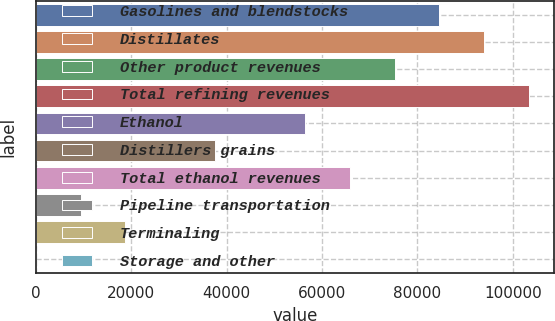Convert chart. <chart><loc_0><loc_0><loc_500><loc_500><bar_chart><fcel>Gasolines and blendstocks<fcel>Distillates<fcel>Other product revenues<fcel>Total refining revenues<fcel>Ethanol<fcel>Distillers grains<fcel>Total ethanol revenues<fcel>Pipeline transportation<fcel>Terminaling<fcel>Storage and other<nl><fcel>84582.3<fcel>93980<fcel>75184.6<fcel>103378<fcel>56389.2<fcel>37593.8<fcel>65786.9<fcel>9400.7<fcel>18798.4<fcel>3<nl></chart> 